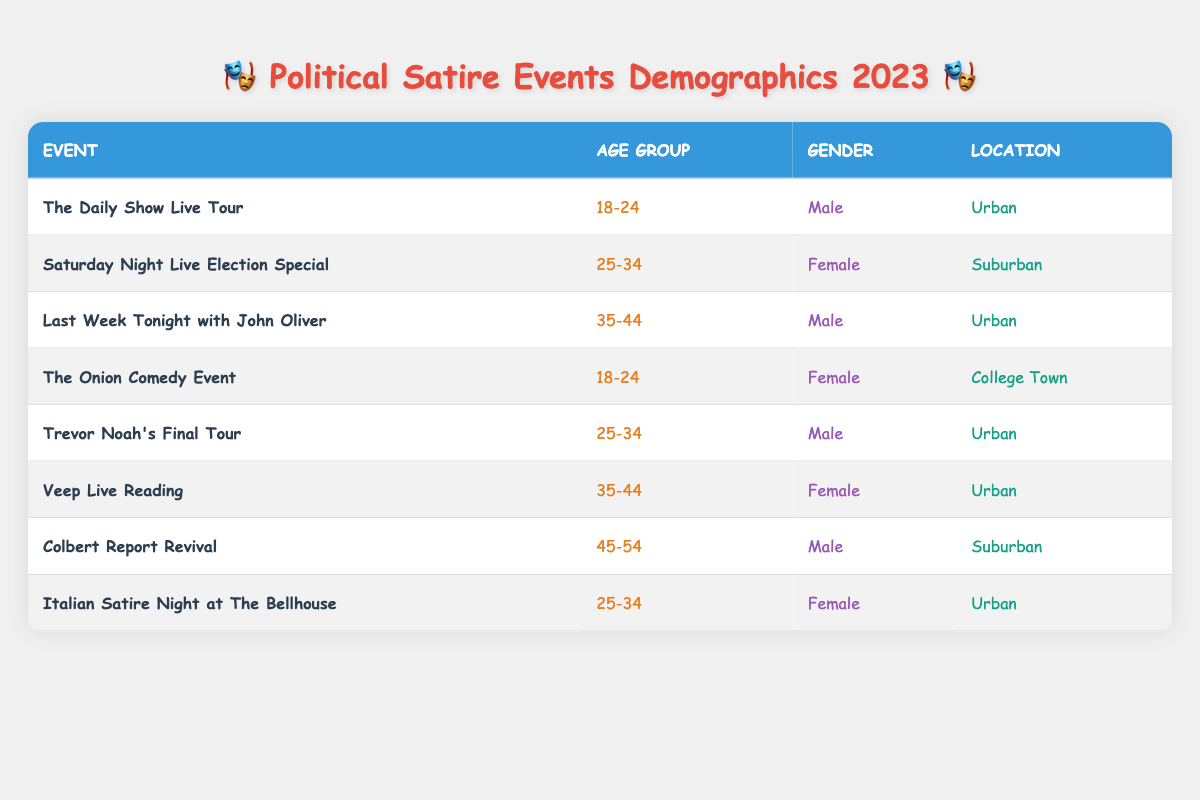What age group has the highest representation in the table? To find the highest representation, we look for the age groups listed in the table: 18-24, 25-34, 35-44, and 45-54. By counting the occurrences, we see that 25-34 appears three times, while the others appear twice or once. Thus, 25-34 has the highest representation.
Answer: 25-34 Is there an event targeting a female audience aged 45-54? We examine the table for any events targeting females in the age group of 45-54. Scanning the rows, we see that the age 45-54 is only represented by "Colbert Report Revival," which lists Male as the gender. Therefore, no such event exists targeting females in this age group.
Answer: No How many events are located in urban areas? We check each row in the location column to count how many events are categorized as Urban. The events in urban locations are "The Daily Show Live Tour," "Last Week Tonight with John Oliver," "Trevor Noah's Final Tour," "Veep Live Reading," and "Italian Satire Night at The Bellhouse," totaling five events.
Answer: 5 What is the gender distribution of the audience for the event "Saturday Night Live Election Special"? We locate the row for "Saturday Night Live Election Special" in the table. The gender listed is Female, allowing us to identify that the event specifically targets a female audience.
Answer: Female How many events have a male audience aged 25-34? We identify the age group of 25-34 and check the gender for any male representation. In the table, "Trevor Noah's Final Tour" fits this criteria as it lists Male for 25-34, giving us one event.
Answer: 1 Are there more events that cater to females than males? We count the total events for each gender. The Female events are from "Saturday Night Live Election Special," "The Onion Comedy Event," "Veep Live Reading," and "Italian Satire Night at The Bellhouse," totaling four. The Male events are from "The Daily Show Live Tour," "Last Week Tonight with John Oliver," "Trevor Noah's Final Tour," and "Colbert Report Revival," totaling four as well. Since both genders have equal representation, the answer is negative.
Answer: No What is the age group of the audience for the event "Italian Satire Night at The Bellhouse"? We locate "Italian Satire Night at The Bellhouse" in the table. The corresponding age group listed is 25-34. This is the direct information from the table.
Answer: 25-34 How many audience members are in the 18-24 age group? From the table, we see that two events cater to the 18-24 age group, specifically "The Daily Show Live Tour" and "The Onion Comedy Event." Thus, the total count is two for this age group.
Answer: 2 